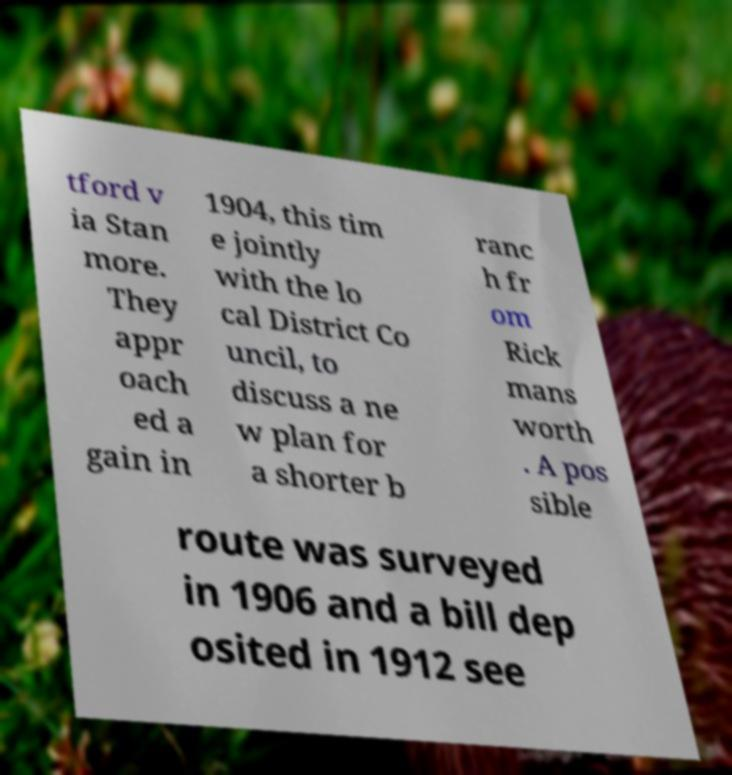Can you accurately transcribe the text from the provided image for me? tford v ia Stan more. They appr oach ed a gain in 1904, this tim e jointly with the lo cal District Co uncil, to discuss a ne w plan for a shorter b ranc h fr om Rick mans worth . A pos sible route was surveyed in 1906 and a bill dep osited in 1912 see 